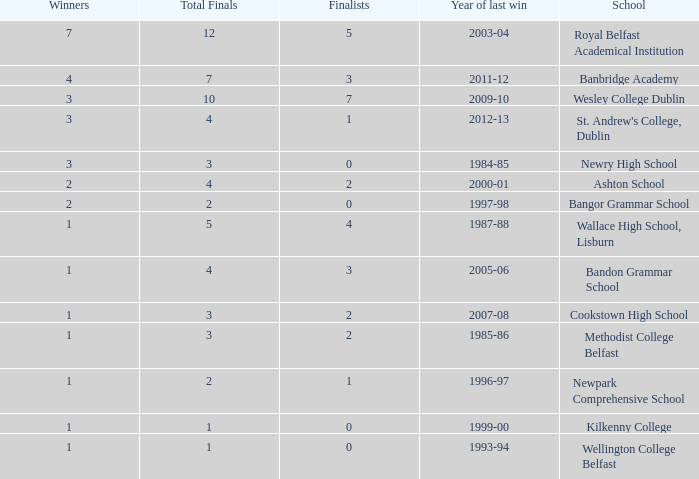What is the name of the school where the year of last win is 1985-86? Methodist College Belfast. 